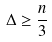<formula> <loc_0><loc_0><loc_500><loc_500>\Delta \geq \frac { n } { 3 }</formula> 